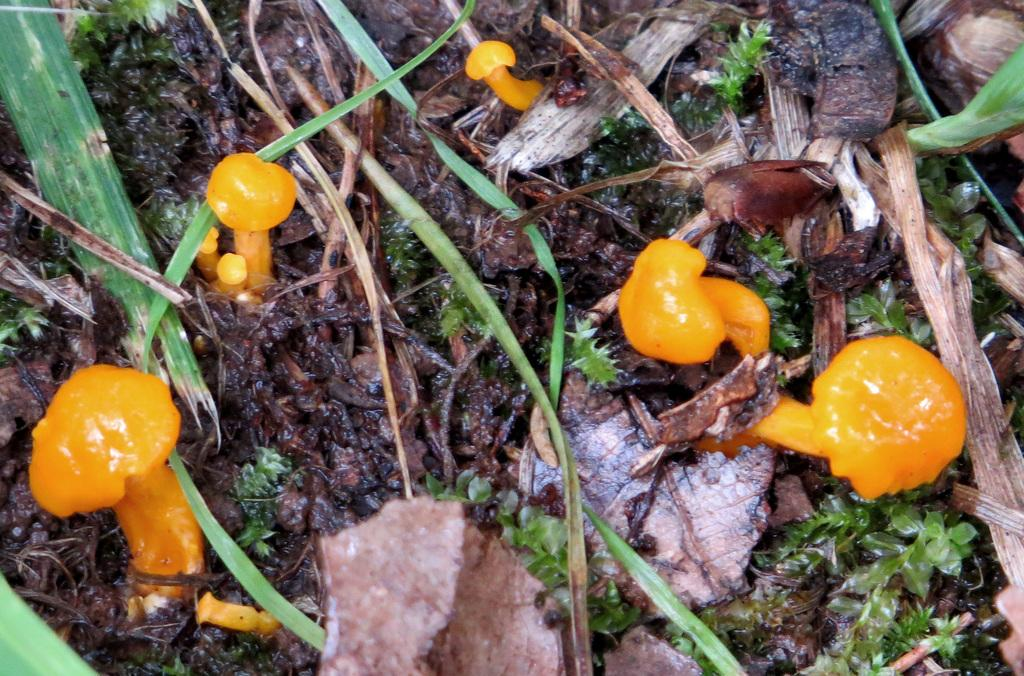What type of fungi can be seen in the image? There are orange-colored mushrooms in the image. What type of vegetation is visible in the image? There is grass visible in the image. What other plant material can be seen in the image? There are leaves in the image. Can you see any cobwebs in the image? There is no mention of cobwebs in the provided facts, so we cannot determine if any are present in the image. 